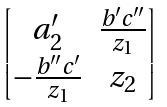Convert formula to latex. <formula><loc_0><loc_0><loc_500><loc_500>\begin{bmatrix} a _ { 2 } ^ { \prime } & \frac { b ^ { \prime } c ^ { \prime \prime } } { z _ { 1 } } \\ - \frac { b ^ { \prime \prime } c ^ { \prime } } { z _ { 1 } } & z _ { 2 } \end{bmatrix}</formula> 